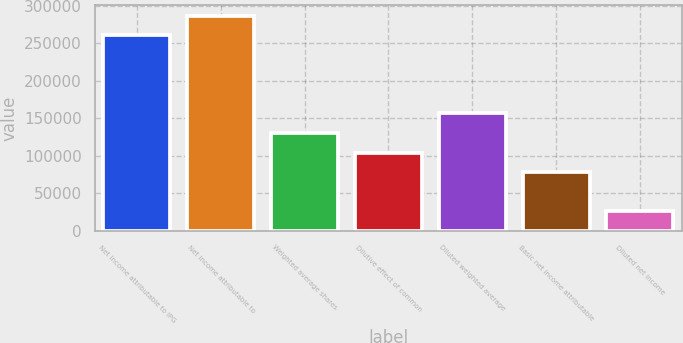Convert chart to OTSL. <chart><loc_0><loc_0><loc_500><loc_500><bar_chart><fcel>Net income attributable to IPG<fcel>Net income attributable to<fcel>Weighted average shares<fcel>Dilutive effect of common<fcel>Diluted weighted average<fcel>Basic net income attributable<fcel>Diluted net income<nl><fcel>260752<fcel>286827<fcel>130378<fcel>104304<fcel>156453<fcel>78229<fcel>26079.6<nl></chart> 